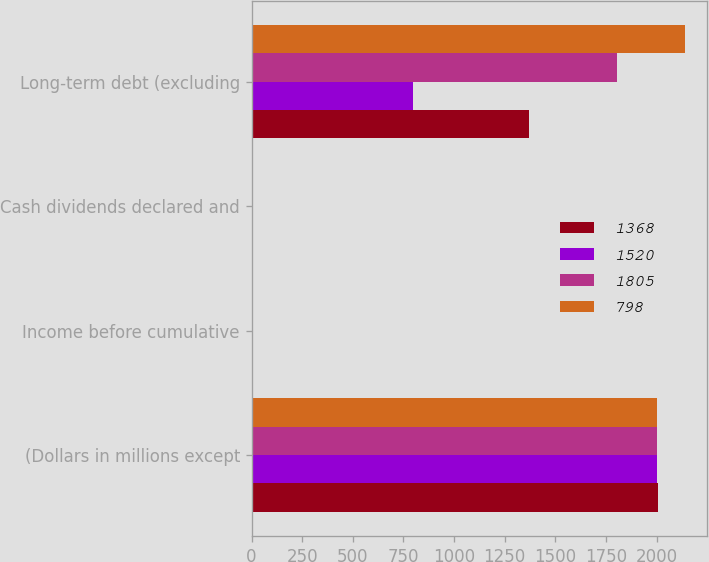Convert chart. <chart><loc_0><loc_0><loc_500><loc_500><stacked_bar_chart><ecel><fcel>(Dollars in millions except<fcel>Income before cumulative<fcel>Cash dividends declared and<fcel>Long-term debt (excluding<nl><fcel>1368<fcel>2005<fcel>4.16<fcel>1.68<fcel>1368<nl><fcel>1520<fcel>2004<fcel>3.75<fcel>1.44<fcel>798<nl><fcel>1805<fcel>2003<fcel>3.02<fcel>1.32<fcel>1805<nl><fcel>798<fcel>2002<fcel>2.5<fcel>1.24<fcel>2142<nl></chart> 